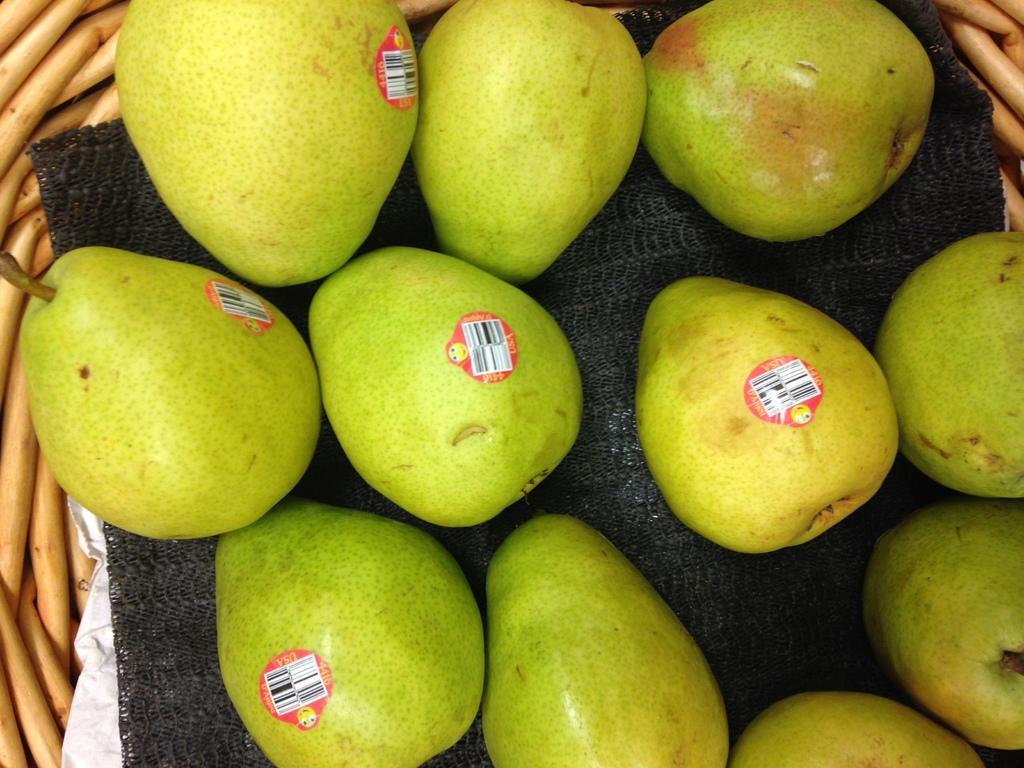Please provide a concise description of this image. In this image there is a basket with a cloth and a few beers in it. 